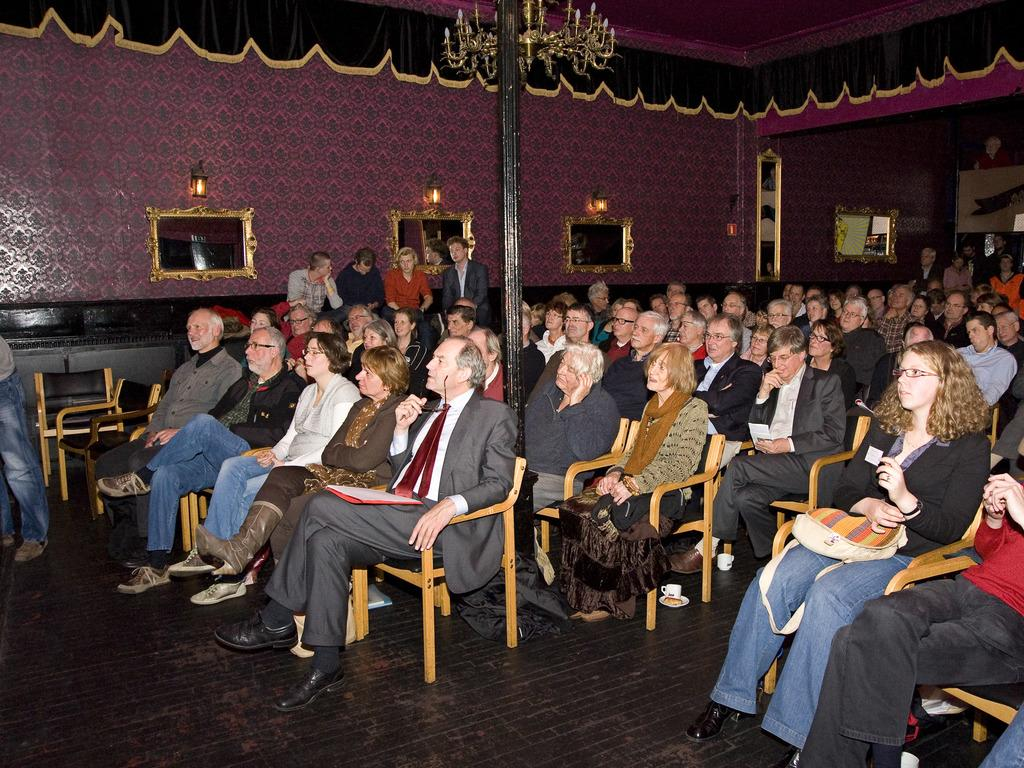What type of location is shown in the image? The image depicts a meeting hall. What are the people in the image doing? People are seated on chairs in the meeting hall. What type of knee pads are being used by the cows in the image? There are no cows or knee pads present in the image; it features a meeting hall with people seated on chairs. 